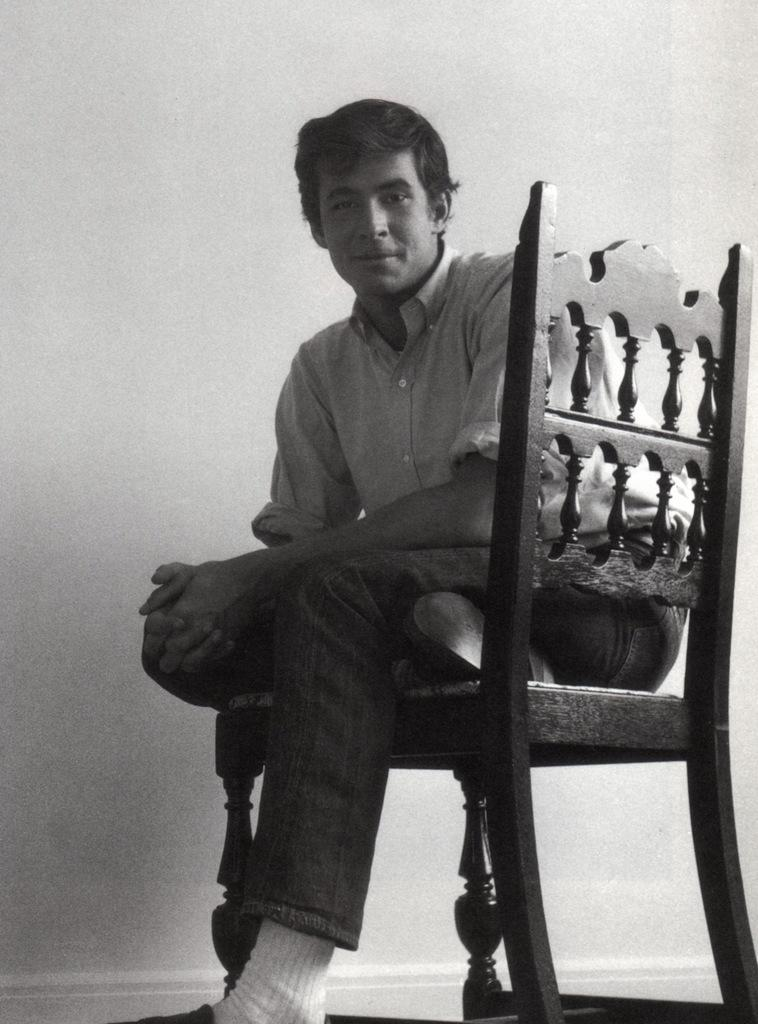What is the color scheme of the image? The image is black and white. What is the man in the image doing? The man is sitting on a chair in the image. What can be seen in the background of the image? There is a wall visible in the background of the image. What type of quartz can be seen on the man's lap in the image? There is no quartz present in the image; the man is simply sitting on a chair. How many lizards are crawling on the wall in the background of the image? There are no lizards present in the image; the background only shows a wall. 